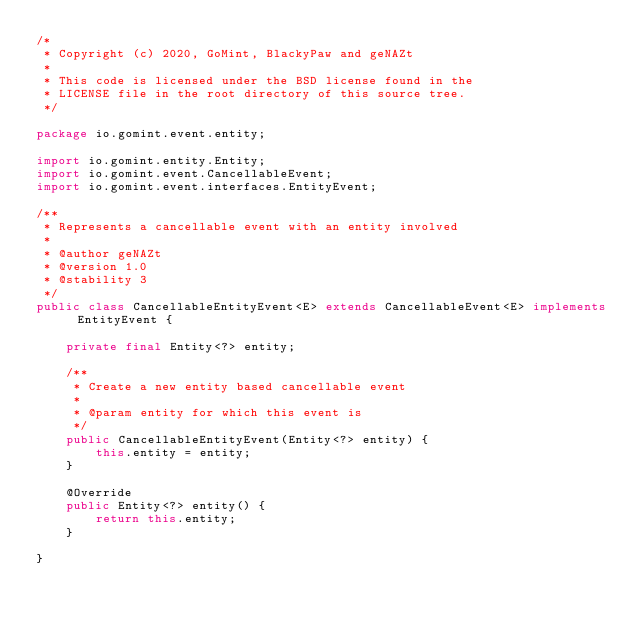Convert code to text. <code><loc_0><loc_0><loc_500><loc_500><_Java_>/*
 * Copyright (c) 2020, GoMint, BlackyPaw and geNAZt
 *
 * This code is licensed under the BSD license found in the
 * LICENSE file in the root directory of this source tree.
 */

package io.gomint.event.entity;

import io.gomint.entity.Entity;
import io.gomint.event.CancellableEvent;
import io.gomint.event.interfaces.EntityEvent;

/**
 * Represents a cancellable event with an entity involved
 *
 * @author geNAZt
 * @version 1.0
 * @stability 3
 */
public class CancellableEntityEvent<E> extends CancellableEvent<E> implements EntityEvent {

    private final Entity<?> entity;

    /**
     * Create a new entity based cancellable event
     *
     * @param entity for which this event is
     */
    public CancellableEntityEvent(Entity<?> entity) {
        this.entity = entity;
    }

    @Override
    public Entity<?> entity() {
        return this.entity;
    }

}
</code> 